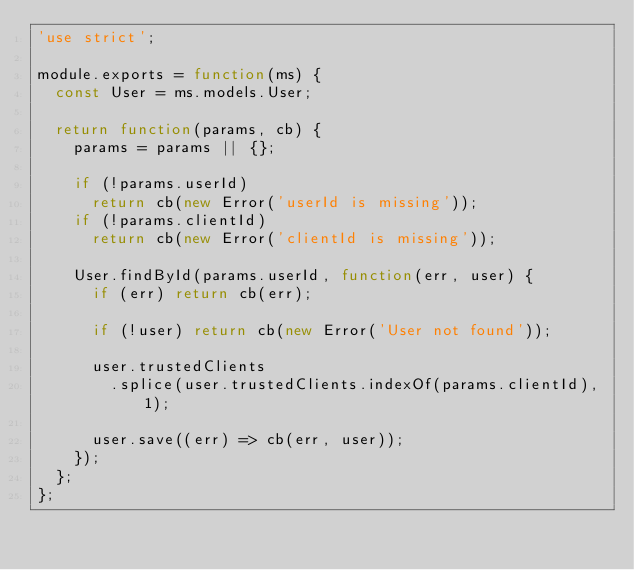Convert code to text. <code><loc_0><loc_0><loc_500><loc_500><_JavaScript_>'use strict';

module.exports = function(ms) {
  const User = ms.models.User;

  return function(params, cb) {
    params = params || {};

    if (!params.userId)
      return cb(new Error('userId is missing'));
    if (!params.clientId)
      return cb(new Error('clientId is missing'));

    User.findById(params.userId, function(err, user) {
      if (err) return cb(err);

      if (!user) return cb(new Error('User not found'));

      user.trustedClients
        .splice(user.trustedClients.indexOf(params.clientId), 1);

      user.save((err) => cb(err, user));
    });
  };
};
</code> 